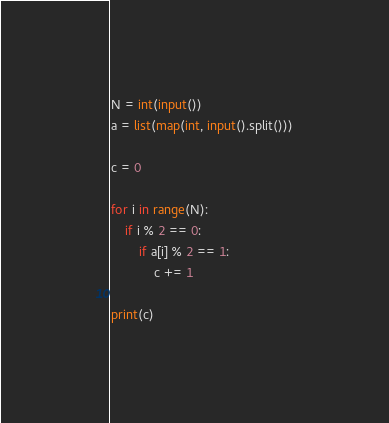Convert code to text. <code><loc_0><loc_0><loc_500><loc_500><_Python_>N = int(input())
a = list(map(int, input().split()))

c = 0

for i in range(N):
    if i % 2 == 0:
        if a[i] % 2 == 1:
            c += 1

print(c)</code> 